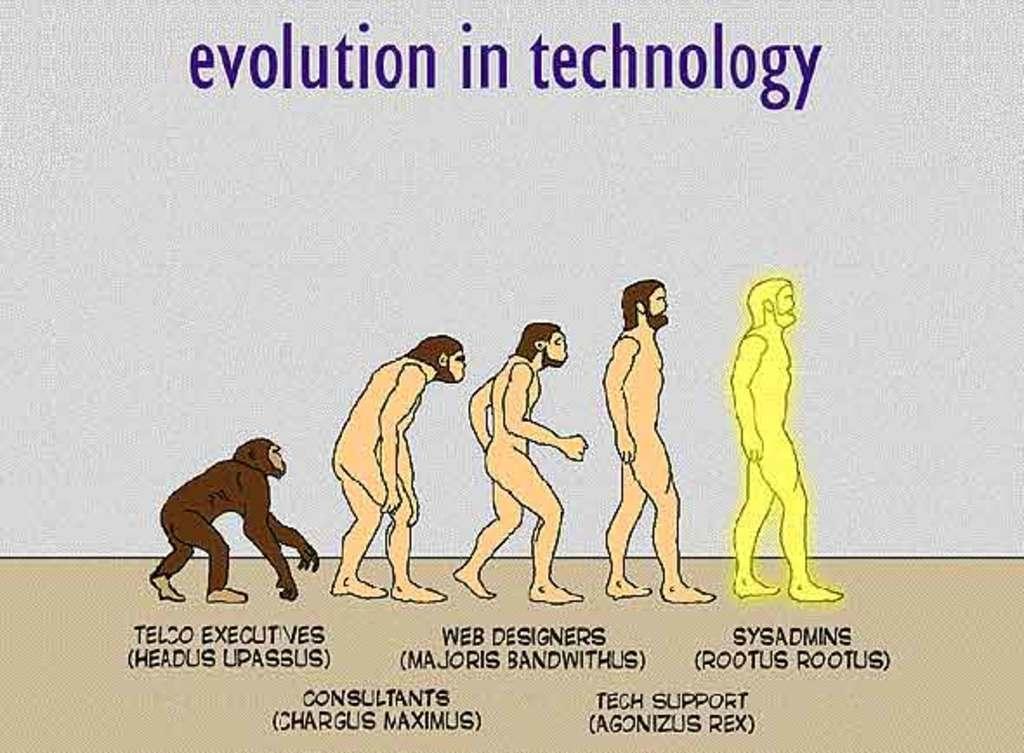In one or two sentences, can you explain what this image depicts? In this image, we can see evolution of a person and some text. 